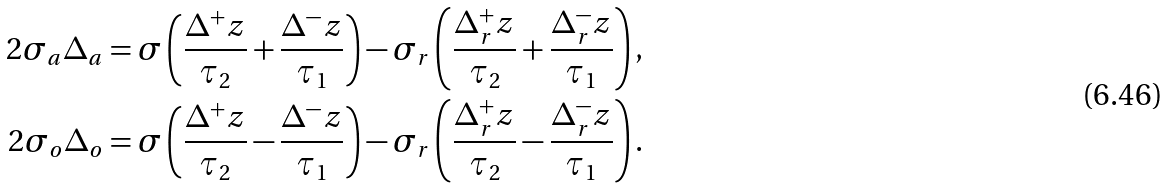<formula> <loc_0><loc_0><loc_500><loc_500>2 \sigma _ { a } \Delta _ { a } = \sigma \left ( \frac { \Delta ^ { + } z } { \tau _ { 2 } } + \frac { \Delta ^ { - } z } { \tau _ { 1 } } \right ) - \sigma _ { r } \left ( \frac { \Delta ^ { + } _ { r } z } { \tau _ { 2 } } + \frac { \Delta ^ { - } _ { r } z } { \tau _ { 1 } } \right ) , \\ 2 \sigma _ { o } \Delta _ { o } = \sigma \left ( \frac { \Delta ^ { + } z } { \tau _ { 2 } } - \frac { \Delta ^ { - } z } { \tau _ { 1 } } \right ) - \sigma _ { r } \left ( \frac { \Delta ^ { + } _ { r } z } { \tau _ { 2 } } - \frac { \Delta ^ { - } _ { r } z } { \tau _ { 1 } } \right ) .</formula> 